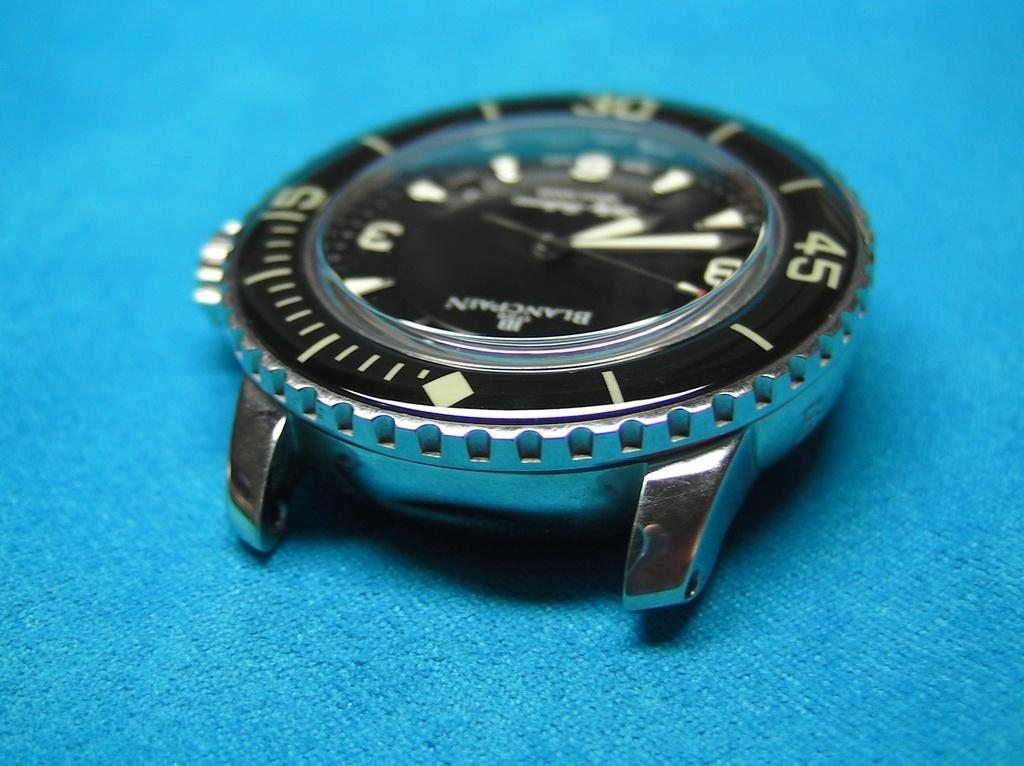Provide a one-sentence caption for the provided image. a BlancPain silver and black wrist watch on blue cloth. 